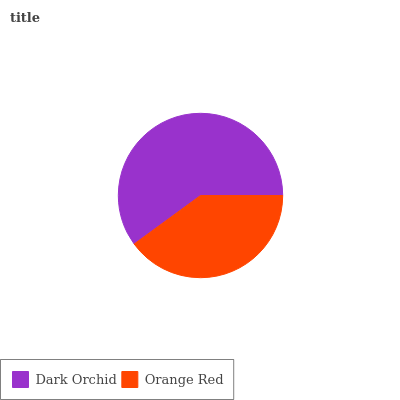Is Orange Red the minimum?
Answer yes or no. Yes. Is Dark Orchid the maximum?
Answer yes or no. Yes. Is Orange Red the maximum?
Answer yes or no. No. Is Dark Orchid greater than Orange Red?
Answer yes or no. Yes. Is Orange Red less than Dark Orchid?
Answer yes or no. Yes. Is Orange Red greater than Dark Orchid?
Answer yes or no. No. Is Dark Orchid less than Orange Red?
Answer yes or no. No. Is Dark Orchid the high median?
Answer yes or no. Yes. Is Orange Red the low median?
Answer yes or no. Yes. Is Orange Red the high median?
Answer yes or no. No. Is Dark Orchid the low median?
Answer yes or no. No. 